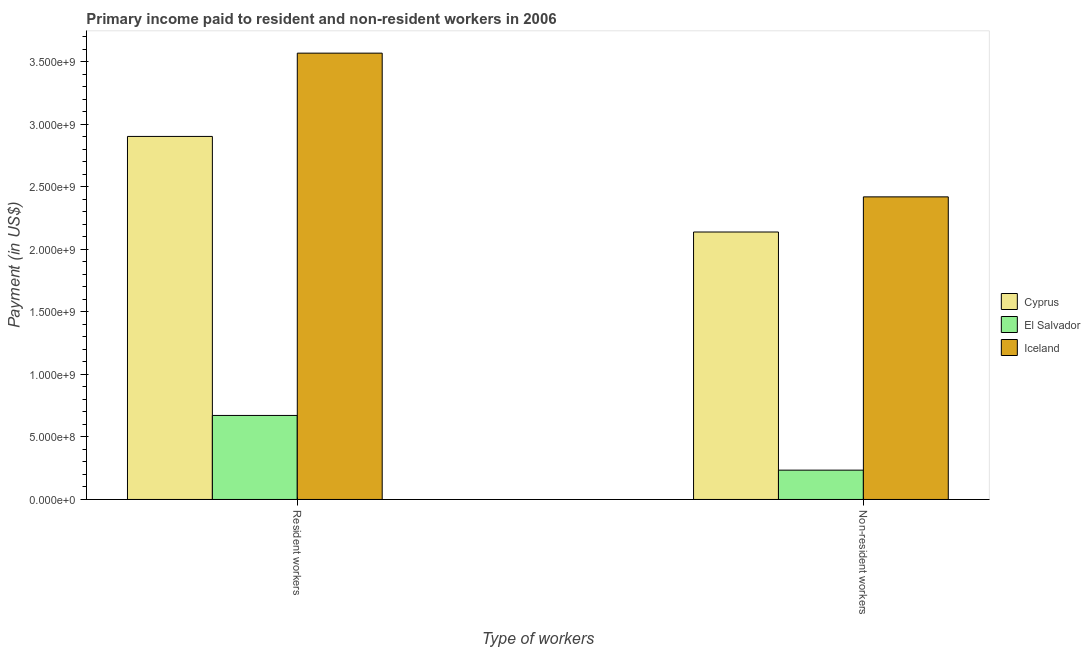How many different coloured bars are there?
Make the answer very short. 3. How many groups of bars are there?
Give a very brief answer. 2. Are the number of bars per tick equal to the number of legend labels?
Offer a very short reply. Yes. How many bars are there on the 1st tick from the right?
Provide a succinct answer. 3. What is the label of the 2nd group of bars from the left?
Offer a terse response. Non-resident workers. What is the payment made to non-resident workers in El Salvador?
Provide a short and direct response. 2.34e+08. Across all countries, what is the maximum payment made to resident workers?
Provide a succinct answer. 3.57e+09. Across all countries, what is the minimum payment made to non-resident workers?
Keep it short and to the point. 2.34e+08. In which country was the payment made to resident workers maximum?
Offer a terse response. Iceland. In which country was the payment made to non-resident workers minimum?
Give a very brief answer. El Salvador. What is the total payment made to resident workers in the graph?
Offer a very short reply. 7.15e+09. What is the difference between the payment made to non-resident workers in Cyprus and that in Iceland?
Make the answer very short. -2.81e+08. What is the difference between the payment made to resident workers in El Salvador and the payment made to non-resident workers in Iceland?
Your answer should be very brief. -1.75e+09. What is the average payment made to resident workers per country?
Your answer should be compact. 2.38e+09. What is the difference between the payment made to non-resident workers and payment made to resident workers in El Salvador?
Make the answer very short. -4.38e+08. What is the ratio of the payment made to non-resident workers in Cyprus to that in El Salvador?
Your answer should be compact. 9.13. Is the payment made to non-resident workers in Cyprus less than that in El Salvador?
Provide a succinct answer. No. In how many countries, is the payment made to non-resident workers greater than the average payment made to non-resident workers taken over all countries?
Provide a succinct answer. 2. What does the 1st bar from the left in Resident workers represents?
Your answer should be compact. Cyprus. What does the 2nd bar from the right in Resident workers represents?
Provide a succinct answer. El Salvador. How many bars are there?
Ensure brevity in your answer.  6. Are all the bars in the graph horizontal?
Make the answer very short. No. What is the difference between two consecutive major ticks on the Y-axis?
Your answer should be compact. 5.00e+08. Are the values on the major ticks of Y-axis written in scientific E-notation?
Keep it short and to the point. Yes. Does the graph contain any zero values?
Your answer should be compact. No. Does the graph contain grids?
Your answer should be compact. No. How many legend labels are there?
Give a very brief answer. 3. What is the title of the graph?
Provide a short and direct response. Primary income paid to resident and non-resident workers in 2006. Does "Morocco" appear as one of the legend labels in the graph?
Provide a succinct answer. No. What is the label or title of the X-axis?
Keep it short and to the point. Type of workers. What is the label or title of the Y-axis?
Keep it short and to the point. Payment (in US$). What is the Payment (in US$) in Cyprus in Resident workers?
Your answer should be compact. 2.90e+09. What is the Payment (in US$) in El Salvador in Resident workers?
Ensure brevity in your answer.  6.72e+08. What is the Payment (in US$) of Iceland in Resident workers?
Your answer should be very brief. 3.57e+09. What is the Payment (in US$) in Cyprus in Non-resident workers?
Provide a succinct answer. 2.14e+09. What is the Payment (in US$) in El Salvador in Non-resident workers?
Offer a terse response. 2.34e+08. What is the Payment (in US$) of Iceland in Non-resident workers?
Offer a terse response. 2.42e+09. Across all Type of workers, what is the maximum Payment (in US$) in Cyprus?
Keep it short and to the point. 2.90e+09. Across all Type of workers, what is the maximum Payment (in US$) in El Salvador?
Offer a very short reply. 6.72e+08. Across all Type of workers, what is the maximum Payment (in US$) of Iceland?
Your response must be concise. 3.57e+09. Across all Type of workers, what is the minimum Payment (in US$) in Cyprus?
Ensure brevity in your answer.  2.14e+09. Across all Type of workers, what is the minimum Payment (in US$) in El Salvador?
Your answer should be compact. 2.34e+08. Across all Type of workers, what is the minimum Payment (in US$) in Iceland?
Provide a succinct answer. 2.42e+09. What is the total Payment (in US$) of Cyprus in the graph?
Give a very brief answer. 5.04e+09. What is the total Payment (in US$) of El Salvador in the graph?
Keep it short and to the point. 9.06e+08. What is the total Payment (in US$) in Iceland in the graph?
Ensure brevity in your answer.  5.99e+09. What is the difference between the Payment (in US$) of Cyprus in Resident workers and that in Non-resident workers?
Give a very brief answer. 7.65e+08. What is the difference between the Payment (in US$) in El Salvador in Resident workers and that in Non-resident workers?
Your answer should be compact. 4.38e+08. What is the difference between the Payment (in US$) of Iceland in Resident workers and that in Non-resident workers?
Your response must be concise. 1.15e+09. What is the difference between the Payment (in US$) of Cyprus in Resident workers and the Payment (in US$) of El Salvador in Non-resident workers?
Your response must be concise. 2.67e+09. What is the difference between the Payment (in US$) of Cyprus in Resident workers and the Payment (in US$) of Iceland in Non-resident workers?
Give a very brief answer. 4.83e+08. What is the difference between the Payment (in US$) in El Salvador in Resident workers and the Payment (in US$) in Iceland in Non-resident workers?
Make the answer very short. -1.75e+09. What is the average Payment (in US$) of Cyprus per Type of workers?
Provide a succinct answer. 2.52e+09. What is the average Payment (in US$) of El Salvador per Type of workers?
Your response must be concise. 4.53e+08. What is the average Payment (in US$) in Iceland per Type of workers?
Make the answer very short. 2.99e+09. What is the difference between the Payment (in US$) of Cyprus and Payment (in US$) of El Salvador in Resident workers?
Provide a short and direct response. 2.23e+09. What is the difference between the Payment (in US$) in Cyprus and Payment (in US$) in Iceland in Resident workers?
Offer a very short reply. -6.66e+08. What is the difference between the Payment (in US$) of El Salvador and Payment (in US$) of Iceland in Resident workers?
Provide a short and direct response. -2.90e+09. What is the difference between the Payment (in US$) of Cyprus and Payment (in US$) of El Salvador in Non-resident workers?
Offer a very short reply. 1.90e+09. What is the difference between the Payment (in US$) of Cyprus and Payment (in US$) of Iceland in Non-resident workers?
Your answer should be very brief. -2.81e+08. What is the difference between the Payment (in US$) of El Salvador and Payment (in US$) of Iceland in Non-resident workers?
Offer a very short reply. -2.19e+09. What is the ratio of the Payment (in US$) of Cyprus in Resident workers to that in Non-resident workers?
Make the answer very short. 1.36. What is the ratio of the Payment (in US$) of El Salvador in Resident workers to that in Non-resident workers?
Offer a very short reply. 2.87. What is the ratio of the Payment (in US$) in Iceland in Resident workers to that in Non-resident workers?
Your response must be concise. 1.48. What is the difference between the highest and the second highest Payment (in US$) of Cyprus?
Provide a succinct answer. 7.65e+08. What is the difference between the highest and the second highest Payment (in US$) in El Salvador?
Give a very brief answer. 4.38e+08. What is the difference between the highest and the second highest Payment (in US$) of Iceland?
Offer a very short reply. 1.15e+09. What is the difference between the highest and the lowest Payment (in US$) in Cyprus?
Offer a terse response. 7.65e+08. What is the difference between the highest and the lowest Payment (in US$) of El Salvador?
Your answer should be compact. 4.38e+08. What is the difference between the highest and the lowest Payment (in US$) in Iceland?
Provide a succinct answer. 1.15e+09. 